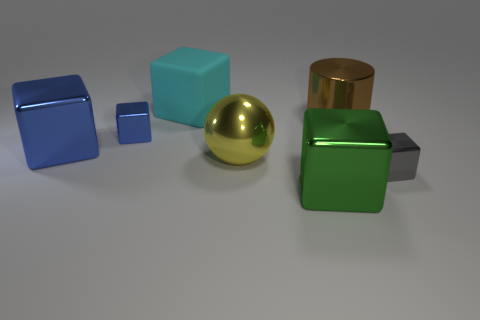Is there a large thing that is in front of the tiny block right of the big block to the right of the cyan rubber cube? Yes, there is a large gold sphere positioned in front of a small blue block, which is to the right of a larger blue block, itself to the right of the cyan rubber cube. 